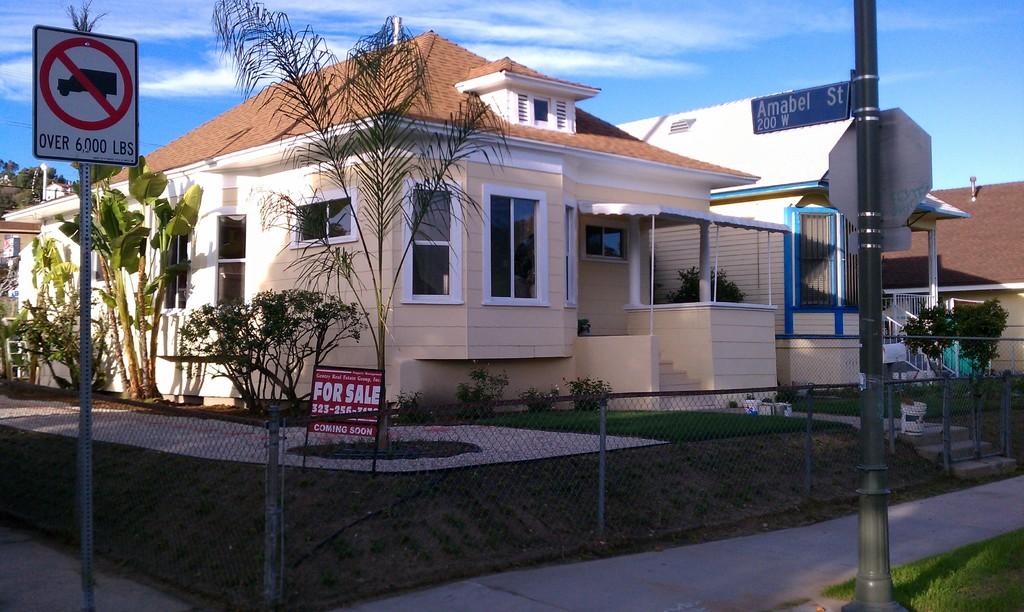Is this house for sale?
Your response must be concise. Yes. What is the name of this street?
Give a very brief answer. Amabel st. 